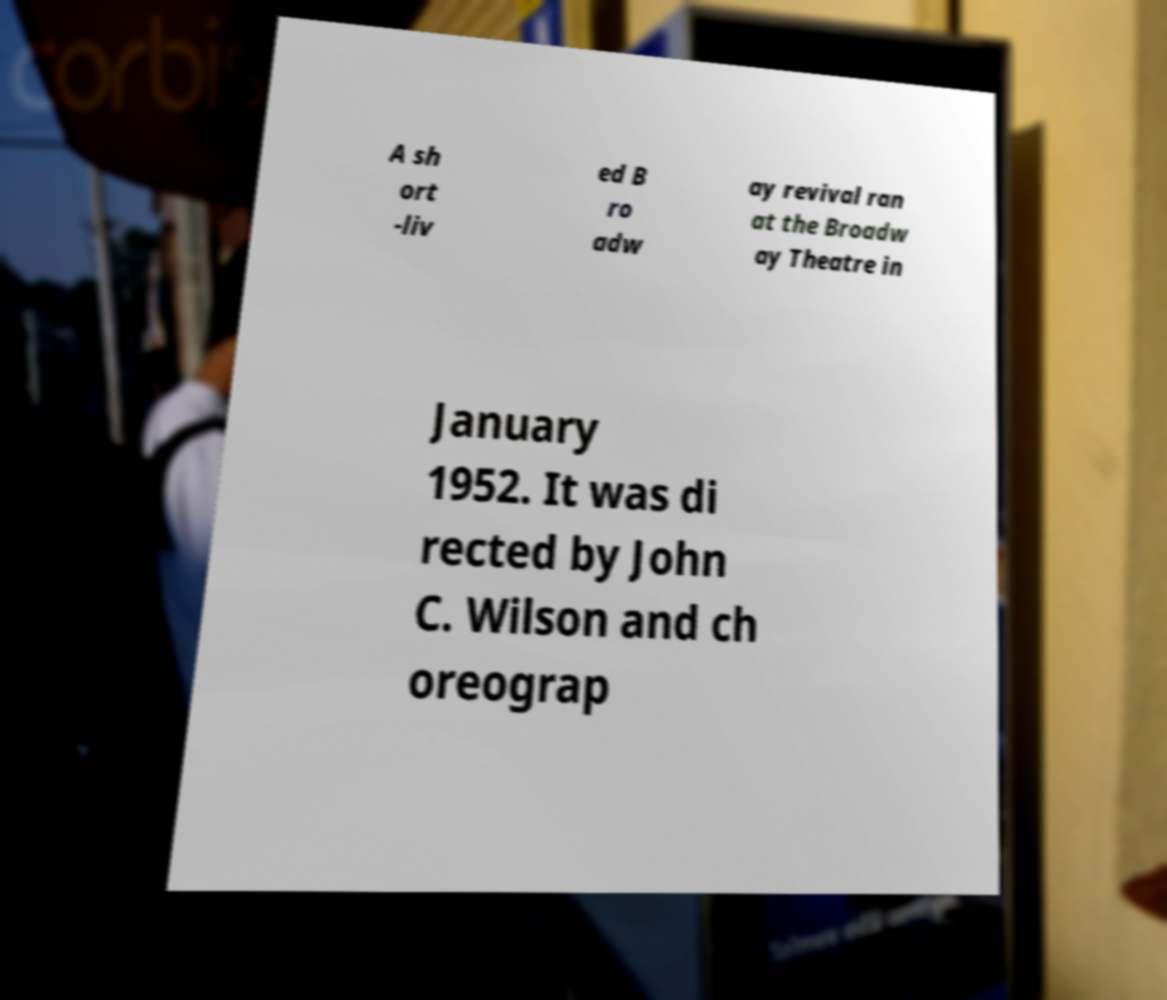I need the written content from this picture converted into text. Can you do that? A sh ort -liv ed B ro adw ay revival ran at the Broadw ay Theatre in January 1952. It was di rected by John C. Wilson and ch oreograp 